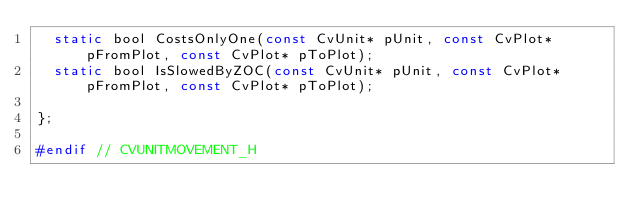Convert code to text. <code><loc_0><loc_0><loc_500><loc_500><_C_>	static bool CostsOnlyOne(const CvUnit* pUnit, const CvPlot* pFromPlot, const CvPlot* pToPlot);
	static bool IsSlowedByZOC(const CvUnit* pUnit, const CvPlot* pFromPlot, const CvPlot* pToPlot);

};

#endif // CVUNITMOVEMENT_H</code> 